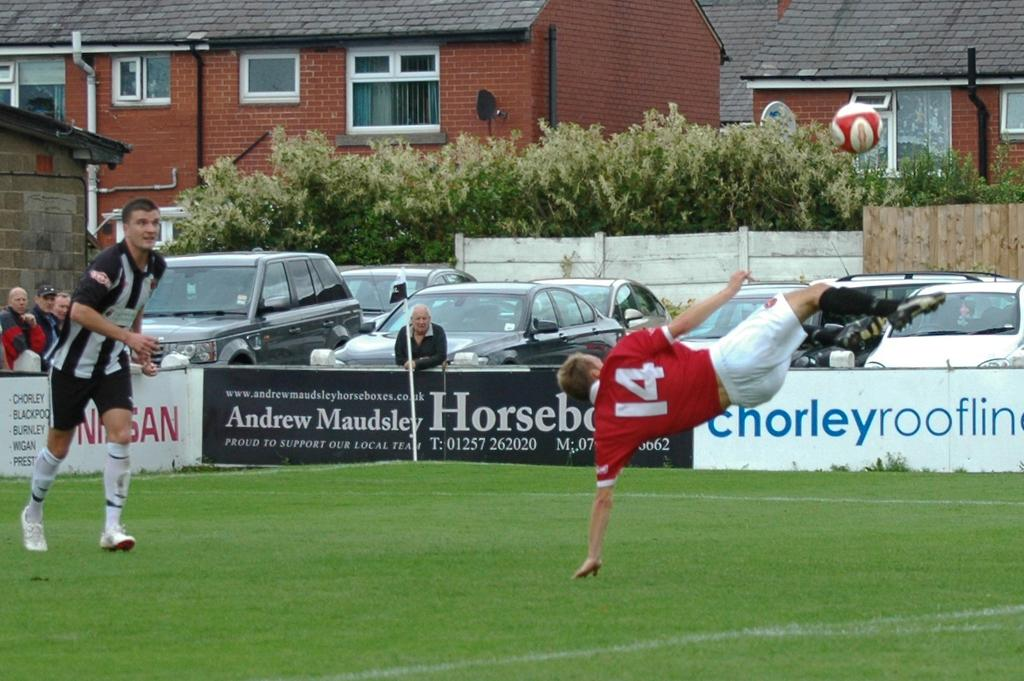<image>
Share a concise interpretation of the image provided. Player number 14 in red attempts a bicycle kick in a soccer game. 